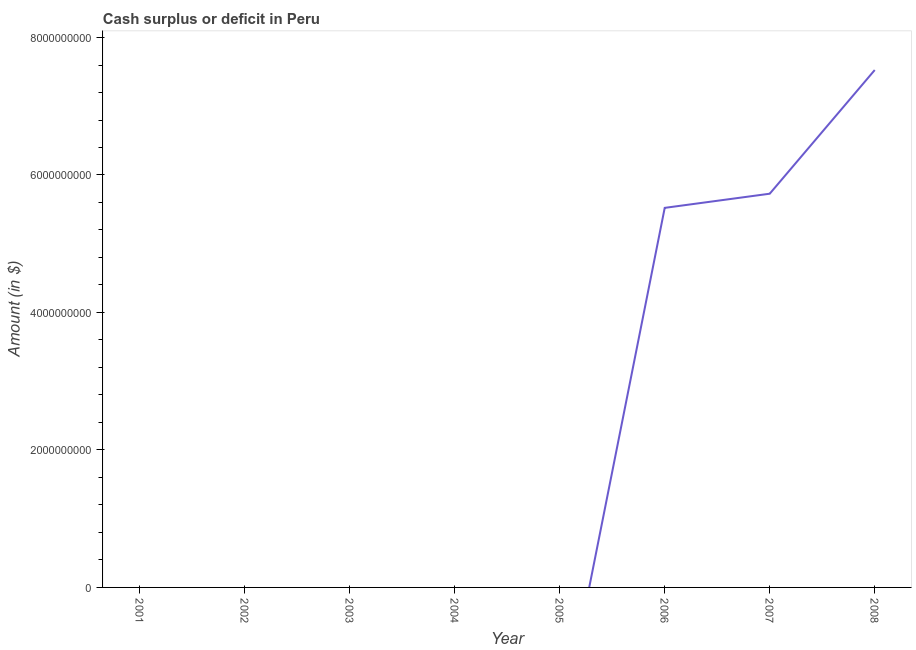Across all years, what is the maximum cash surplus or deficit?
Your answer should be very brief. 7.53e+09. Across all years, what is the minimum cash surplus or deficit?
Your answer should be compact. 0. What is the sum of the cash surplus or deficit?
Your answer should be very brief. 1.88e+1. What is the difference between the cash surplus or deficit in 2006 and 2008?
Offer a terse response. -2.01e+09. What is the average cash surplus or deficit per year?
Provide a short and direct response. 2.35e+09. What is the median cash surplus or deficit?
Your response must be concise. 0. In how many years, is the cash surplus or deficit greater than 2000000000 $?
Keep it short and to the point. 3. What is the difference between the highest and the second highest cash surplus or deficit?
Your answer should be compact. 1.80e+09. What is the difference between the highest and the lowest cash surplus or deficit?
Keep it short and to the point. 7.53e+09. In how many years, is the cash surplus or deficit greater than the average cash surplus or deficit taken over all years?
Offer a terse response. 3. What is the difference between two consecutive major ticks on the Y-axis?
Give a very brief answer. 2.00e+09. Are the values on the major ticks of Y-axis written in scientific E-notation?
Provide a succinct answer. No. Does the graph contain any zero values?
Your answer should be very brief. Yes. Does the graph contain grids?
Keep it short and to the point. No. What is the title of the graph?
Ensure brevity in your answer.  Cash surplus or deficit in Peru. What is the label or title of the X-axis?
Your answer should be compact. Year. What is the label or title of the Y-axis?
Give a very brief answer. Amount (in $). What is the Amount (in $) in 2002?
Your answer should be compact. 0. What is the Amount (in $) in 2003?
Ensure brevity in your answer.  0. What is the Amount (in $) of 2004?
Give a very brief answer. 0. What is the Amount (in $) of 2005?
Ensure brevity in your answer.  0. What is the Amount (in $) of 2006?
Your answer should be compact. 5.52e+09. What is the Amount (in $) of 2007?
Your response must be concise. 5.73e+09. What is the Amount (in $) in 2008?
Provide a succinct answer. 7.53e+09. What is the difference between the Amount (in $) in 2006 and 2007?
Provide a short and direct response. -2.06e+08. What is the difference between the Amount (in $) in 2006 and 2008?
Your answer should be very brief. -2.01e+09. What is the difference between the Amount (in $) in 2007 and 2008?
Offer a terse response. -1.80e+09. What is the ratio of the Amount (in $) in 2006 to that in 2008?
Your response must be concise. 0.73. What is the ratio of the Amount (in $) in 2007 to that in 2008?
Your answer should be very brief. 0.76. 